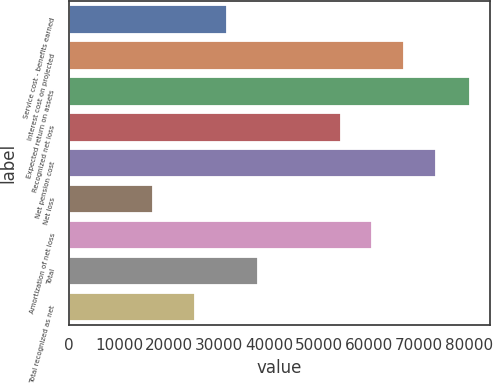Convert chart to OTSL. <chart><loc_0><loc_0><loc_500><loc_500><bar_chart><fcel>Service cost - benefits earned<fcel>Interest cost on projected<fcel>Expected return on assets<fcel>Recognized net loss<fcel>Net pension cost<fcel>Net loss<fcel>Amortization of net loss<fcel>Total<fcel>Total recognized as net<nl><fcel>31457.5<fcel>66937<fcel>80102<fcel>54254<fcel>73278.5<fcel>16687<fcel>60595.5<fcel>37799<fcel>25116<nl></chart> 